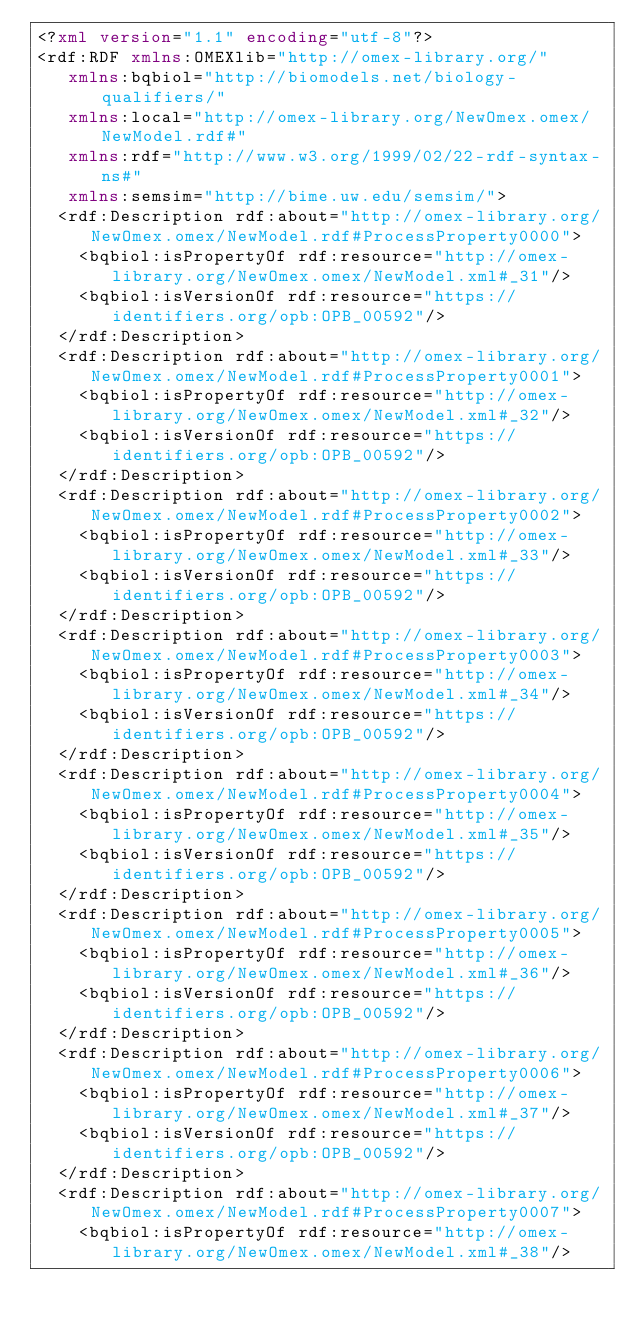<code> <loc_0><loc_0><loc_500><loc_500><_XML_><?xml version="1.1" encoding="utf-8"?>
<rdf:RDF xmlns:OMEXlib="http://omex-library.org/"
   xmlns:bqbiol="http://biomodels.net/biology-qualifiers/"
   xmlns:local="http://omex-library.org/NewOmex.omex/NewModel.rdf#"
   xmlns:rdf="http://www.w3.org/1999/02/22-rdf-syntax-ns#"
   xmlns:semsim="http://bime.uw.edu/semsim/">
  <rdf:Description rdf:about="http://omex-library.org/NewOmex.omex/NewModel.rdf#ProcessProperty0000">
    <bqbiol:isPropertyOf rdf:resource="http://omex-library.org/NewOmex.omex/NewModel.xml#_31"/>
    <bqbiol:isVersionOf rdf:resource="https://identifiers.org/opb:OPB_00592"/>
  </rdf:Description>
  <rdf:Description rdf:about="http://omex-library.org/NewOmex.omex/NewModel.rdf#ProcessProperty0001">
    <bqbiol:isPropertyOf rdf:resource="http://omex-library.org/NewOmex.omex/NewModel.xml#_32"/>
    <bqbiol:isVersionOf rdf:resource="https://identifiers.org/opb:OPB_00592"/>
  </rdf:Description>
  <rdf:Description rdf:about="http://omex-library.org/NewOmex.omex/NewModel.rdf#ProcessProperty0002">
    <bqbiol:isPropertyOf rdf:resource="http://omex-library.org/NewOmex.omex/NewModel.xml#_33"/>
    <bqbiol:isVersionOf rdf:resource="https://identifiers.org/opb:OPB_00592"/>
  </rdf:Description>
  <rdf:Description rdf:about="http://omex-library.org/NewOmex.omex/NewModel.rdf#ProcessProperty0003">
    <bqbiol:isPropertyOf rdf:resource="http://omex-library.org/NewOmex.omex/NewModel.xml#_34"/>
    <bqbiol:isVersionOf rdf:resource="https://identifiers.org/opb:OPB_00592"/>
  </rdf:Description>
  <rdf:Description rdf:about="http://omex-library.org/NewOmex.omex/NewModel.rdf#ProcessProperty0004">
    <bqbiol:isPropertyOf rdf:resource="http://omex-library.org/NewOmex.omex/NewModel.xml#_35"/>
    <bqbiol:isVersionOf rdf:resource="https://identifiers.org/opb:OPB_00592"/>
  </rdf:Description>
  <rdf:Description rdf:about="http://omex-library.org/NewOmex.omex/NewModel.rdf#ProcessProperty0005">
    <bqbiol:isPropertyOf rdf:resource="http://omex-library.org/NewOmex.omex/NewModel.xml#_36"/>
    <bqbiol:isVersionOf rdf:resource="https://identifiers.org/opb:OPB_00592"/>
  </rdf:Description>
  <rdf:Description rdf:about="http://omex-library.org/NewOmex.omex/NewModel.rdf#ProcessProperty0006">
    <bqbiol:isPropertyOf rdf:resource="http://omex-library.org/NewOmex.omex/NewModel.xml#_37"/>
    <bqbiol:isVersionOf rdf:resource="https://identifiers.org/opb:OPB_00592"/>
  </rdf:Description>
  <rdf:Description rdf:about="http://omex-library.org/NewOmex.omex/NewModel.rdf#ProcessProperty0007">
    <bqbiol:isPropertyOf rdf:resource="http://omex-library.org/NewOmex.omex/NewModel.xml#_38"/></code> 